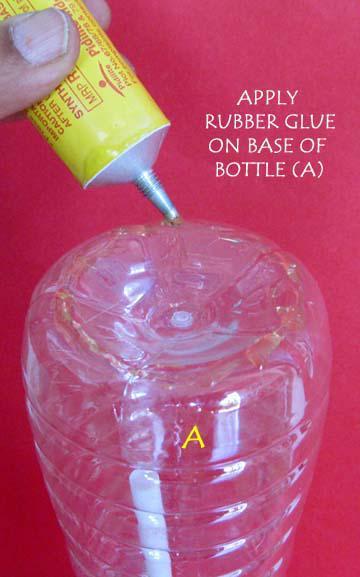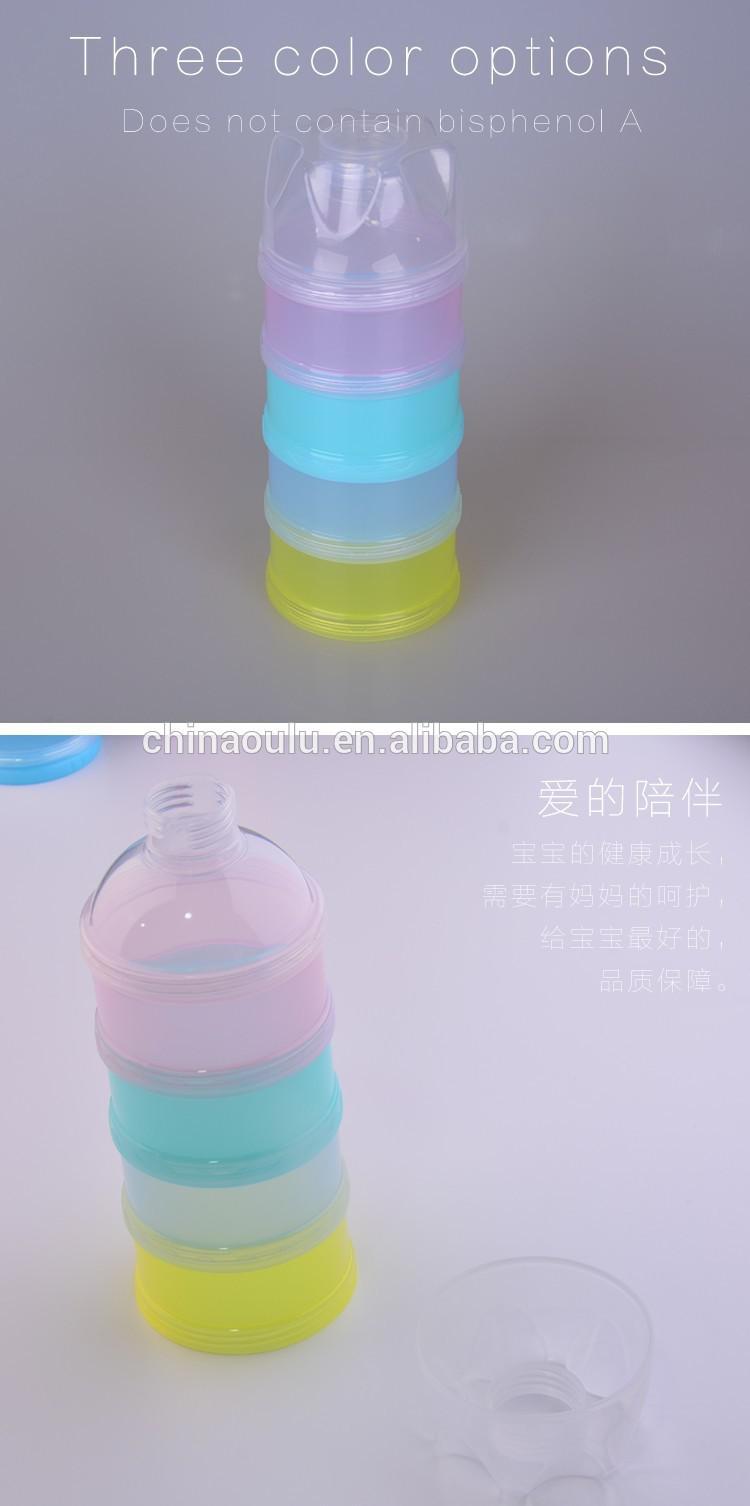The first image is the image on the left, the second image is the image on the right. Given the left and right images, does the statement "There is at least one tennis ball near a water bottle." hold true? Answer yes or no. No. The first image is the image on the left, the second image is the image on the right. Examine the images to the left and right. Is the description "At least one image includes a yellow tennis ball next to a water bottle." accurate? Answer yes or no. No. 